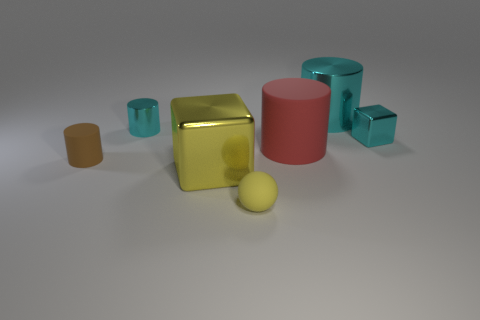There is a metal thing that is the same color as the sphere; what is its size?
Offer a very short reply. Large. What size is the cylinder that is both left of the large cyan cylinder and right of the yellow matte object?
Provide a short and direct response. Large. What material is the small brown thing that is to the left of the metallic block that is to the left of the cube to the right of the red cylinder made of?
Provide a short and direct response. Rubber. There is a tiny thing that is the same color as the large block; what is its material?
Your response must be concise. Rubber. Do the matte thing that is left of the small sphere and the tiny cylinder behind the small brown cylinder have the same color?
Offer a very short reply. No. What is the shape of the big red rubber thing in front of the tiny cylinder behind the metal block that is to the right of the small yellow rubber thing?
Your answer should be very brief. Cylinder. There is a small thing that is in front of the large red matte cylinder and on the left side of the yellow metal object; what is its shape?
Your response must be concise. Cylinder. What number of tiny brown things are to the right of the cyan metal thing that is in front of the cyan cylinder in front of the large cyan cylinder?
Provide a succinct answer. 0. There is a brown object that is the same shape as the red object; what is its size?
Offer a terse response. Small. Are there any other things that are the same size as the brown matte object?
Give a very brief answer. Yes. 